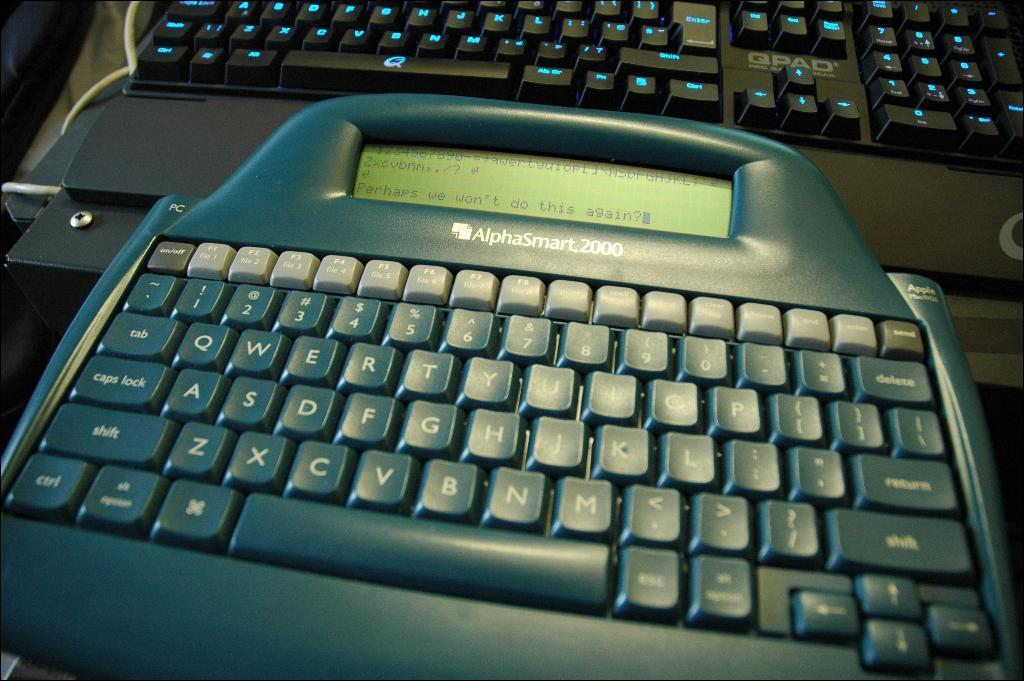What type of device is present in the image that has both a keyboard and a display? There is an object with both a keyboard and a display in the image. Can you describe the keyboard in the background of the image? There is a keyboard in the background of the image. What else can be seen in the background of the image? There is a cable and other objects in the background of the image. What does the uncle look like in the image? There is no uncle present in the image. Can you describe the stick used by the person in the image? There is no person or stick present in the image. 